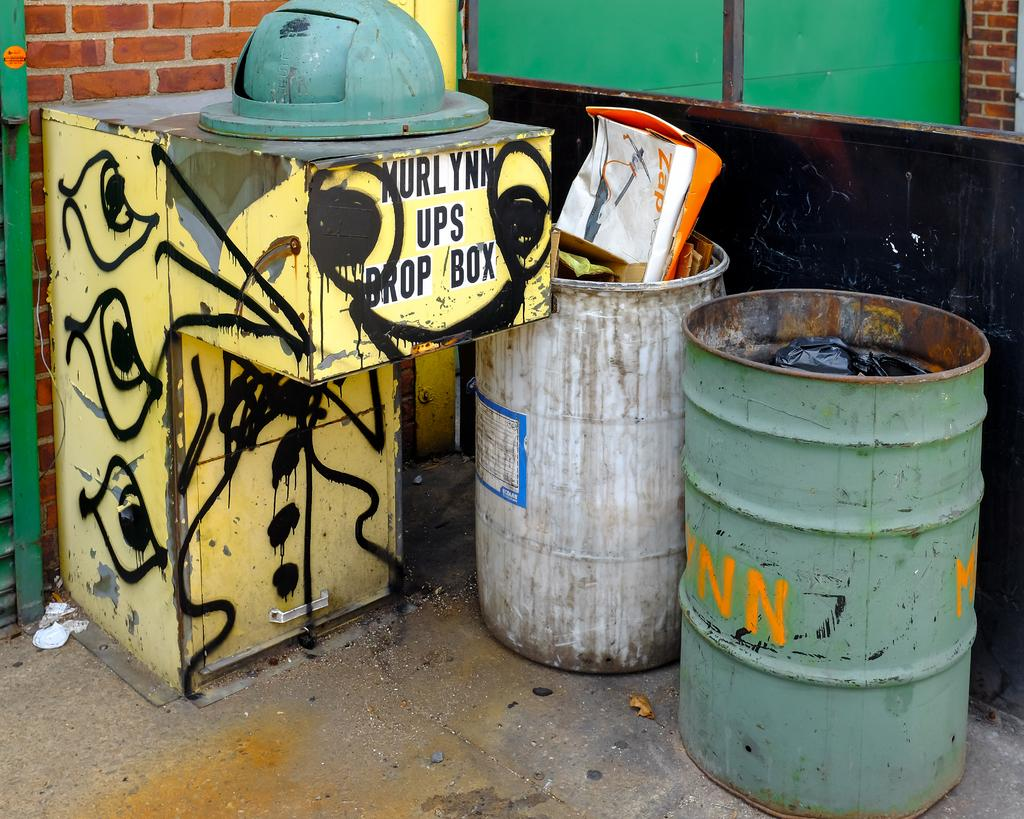<image>
Provide a brief description of the given image. A yellow drop box is labeled for Murlynn and UPS. 